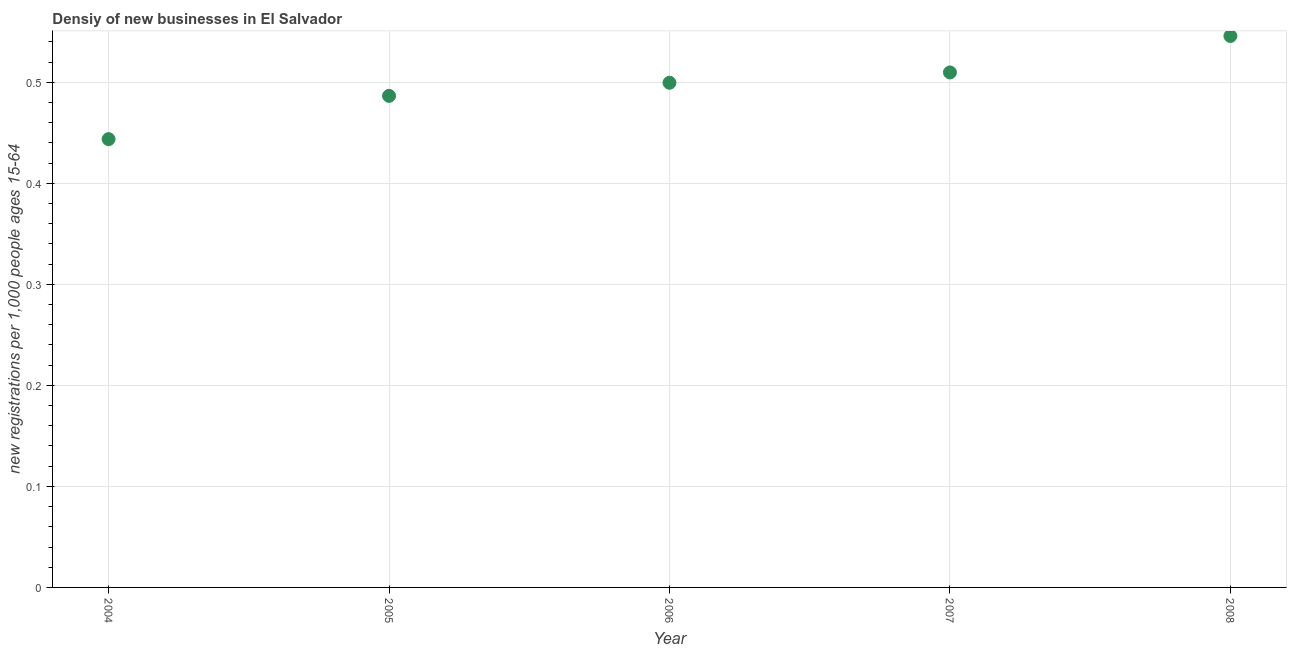What is the density of new business in 2008?
Offer a very short reply. 0.55. Across all years, what is the maximum density of new business?
Give a very brief answer. 0.55. Across all years, what is the minimum density of new business?
Provide a succinct answer. 0.44. What is the sum of the density of new business?
Your answer should be very brief. 2.49. What is the difference between the density of new business in 2006 and 2008?
Provide a short and direct response. -0.05. What is the average density of new business per year?
Give a very brief answer. 0.5. What is the median density of new business?
Your answer should be compact. 0.5. In how many years, is the density of new business greater than 0.4 ?
Your answer should be compact. 5. Do a majority of the years between 2007 and 2004 (inclusive) have density of new business greater than 0.32000000000000006 ?
Provide a succinct answer. Yes. What is the ratio of the density of new business in 2004 to that in 2005?
Provide a succinct answer. 0.91. Is the density of new business in 2005 less than that in 2006?
Offer a very short reply. Yes. What is the difference between the highest and the second highest density of new business?
Give a very brief answer. 0.04. Is the sum of the density of new business in 2006 and 2007 greater than the maximum density of new business across all years?
Keep it short and to the point. Yes. What is the difference between the highest and the lowest density of new business?
Ensure brevity in your answer.  0.1. Does the density of new business monotonically increase over the years?
Give a very brief answer. Yes. What is the difference between two consecutive major ticks on the Y-axis?
Provide a short and direct response. 0.1. Are the values on the major ticks of Y-axis written in scientific E-notation?
Give a very brief answer. No. What is the title of the graph?
Offer a very short reply. Densiy of new businesses in El Salvador. What is the label or title of the X-axis?
Offer a very short reply. Year. What is the label or title of the Y-axis?
Offer a very short reply. New registrations per 1,0 people ages 15-64. What is the new registrations per 1,000 people ages 15-64 in 2004?
Make the answer very short. 0.44. What is the new registrations per 1,000 people ages 15-64 in 2005?
Provide a short and direct response. 0.49. What is the new registrations per 1,000 people ages 15-64 in 2006?
Provide a succinct answer. 0.5. What is the new registrations per 1,000 people ages 15-64 in 2007?
Provide a short and direct response. 0.51. What is the new registrations per 1,000 people ages 15-64 in 2008?
Your answer should be compact. 0.55. What is the difference between the new registrations per 1,000 people ages 15-64 in 2004 and 2005?
Offer a very short reply. -0.04. What is the difference between the new registrations per 1,000 people ages 15-64 in 2004 and 2006?
Your answer should be very brief. -0.06. What is the difference between the new registrations per 1,000 people ages 15-64 in 2004 and 2007?
Your answer should be very brief. -0.07. What is the difference between the new registrations per 1,000 people ages 15-64 in 2004 and 2008?
Keep it short and to the point. -0.1. What is the difference between the new registrations per 1,000 people ages 15-64 in 2005 and 2006?
Keep it short and to the point. -0.01. What is the difference between the new registrations per 1,000 people ages 15-64 in 2005 and 2007?
Your response must be concise. -0.02. What is the difference between the new registrations per 1,000 people ages 15-64 in 2005 and 2008?
Ensure brevity in your answer.  -0.06. What is the difference between the new registrations per 1,000 people ages 15-64 in 2006 and 2007?
Offer a terse response. -0.01. What is the difference between the new registrations per 1,000 people ages 15-64 in 2006 and 2008?
Provide a short and direct response. -0.05. What is the difference between the new registrations per 1,000 people ages 15-64 in 2007 and 2008?
Make the answer very short. -0.04. What is the ratio of the new registrations per 1,000 people ages 15-64 in 2004 to that in 2005?
Your answer should be compact. 0.91. What is the ratio of the new registrations per 1,000 people ages 15-64 in 2004 to that in 2006?
Give a very brief answer. 0.89. What is the ratio of the new registrations per 1,000 people ages 15-64 in 2004 to that in 2007?
Make the answer very short. 0.87. What is the ratio of the new registrations per 1,000 people ages 15-64 in 2004 to that in 2008?
Make the answer very short. 0.81. What is the ratio of the new registrations per 1,000 people ages 15-64 in 2005 to that in 2007?
Your response must be concise. 0.95. What is the ratio of the new registrations per 1,000 people ages 15-64 in 2005 to that in 2008?
Provide a short and direct response. 0.89. What is the ratio of the new registrations per 1,000 people ages 15-64 in 2006 to that in 2008?
Ensure brevity in your answer.  0.92. What is the ratio of the new registrations per 1,000 people ages 15-64 in 2007 to that in 2008?
Your answer should be very brief. 0.93. 